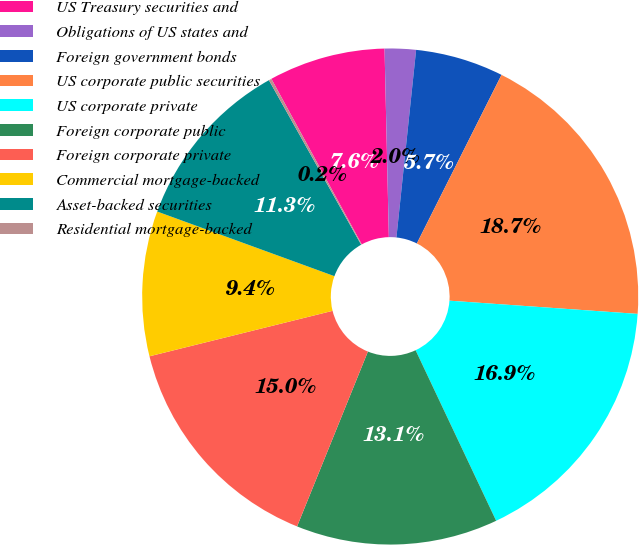<chart> <loc_0><loc_0><loc_500><loc_500><pie_chart><fcel>US Treasury securities and<fcel>Obligations of US states and<fcel>Foreign government bonds<fcel>US corporate public securities<fcel>US corporate private<fcel>Foreign corporate public<fcel>Foreign corporate private<fcel>Commercial mortgage-backed<fcel>Asset-backed securities<fcel>Residential mortgage-backed<nl><fcel>7.59%<fcel>2.03%<fcel>5.74%<fcel>18.71%<fcel>16.86%<fcel>13.15%<fcel>15.0%<fcel>9.44%<fcel>11.3%<fcel>0.18%<nl></chart> 